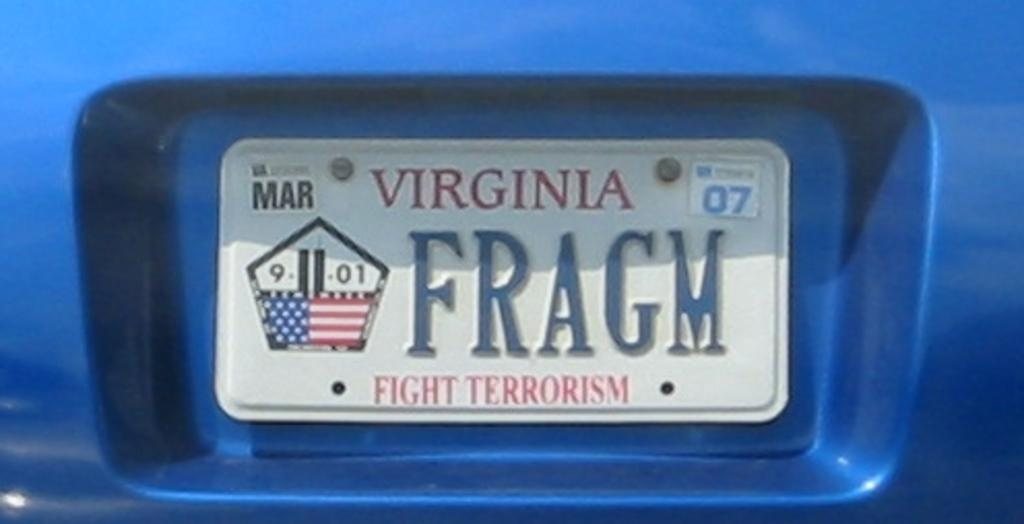Provide a one-sentence caption for the provided image. A Virginia license plate says "fight terrorism" at the bottom. 